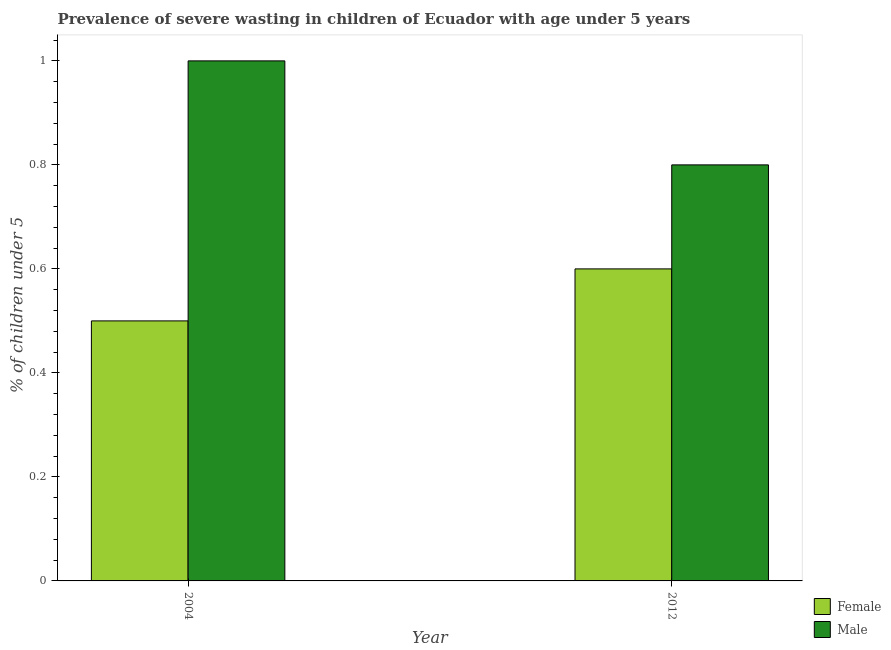How many different coloured bars are there?
Give a very brief answer. 2. Are the number of bars on each tick of the X-axis equal?
Provide a succinct answer. Yes. How many bars are there on the 1st tick from the left?
Keep it short and to the point. 2. What is the label of the 2nd group of bars from the left?
Provide a short and direct response. 2012. In how many cases, is the number of bars for a given year not equal to the number of legend labels?
Offer a terse response. 0. What is the percentage of undernourished female children in 2004?
Provide a short and direct response. 0.5. Across all years, what is the maximum percentage of undernourished female children?
Ensure brevity in your answer.  0.6. Across all years, what is the minimum percentage of undernourished male children?
Offer a very short reply. 0.8. In which year was the percentage of undernourished male children maximum?
Provide a short and direct response. 2004. In which year was the percentage of undernourished female children minimum?
Your answer should be compact. 2004. What is the total percentage of undernourished female children in the graph?
Offer a terse response. 1.1. What is the difference between the percentage of undernourished female children in 2004 and that in 2012?
Your answer should be compact. -0.1. What is the difference between the percentage of undernourished male children in 2012 and the percentage of undernourished female children in 2004?
Ensure brevity in your answer.  -0.2. What is the average percentage of undernourished male children per year?
Offer a terse response. 0.9. In the year 2012, what is the difference between the percentage of undernourished female children and percentage of undernourished male children?
Offer a terse response. 0. What is the ratio of the percentage of undernourished male children in 2004 to that in 2012?
Provide a succinct answer. 1.25. What does the 1st bar from the left in 2004 represents?
Give a very brief answer. Female. How many years are there in the graph?
Provide a short and direct response. 2. How many legend labels are there?
Give a very brief answer. 2. How are the legend labels stacked?
Ensure brevity in your answer.  Vertical. What is the title of the graph?
Keep it short and to the point. Prevalence of severe wasting in children of Ecuador with age under 5 years. What is the label or title of the X-axis?
Your response must be concise. Year. What is the label or title of the Y-axis?
Provide a succinct answer.  % of children under 5. What is the  % of children under 5 of Female in 2004?
Your response must be concise. 0.5. What is the  % of children under 5 of Female in 2012?
Keep it short and to the point. 0.6. What is the  % of children under 5 of Male in 2012?
Give a very brief answer. 0.8. Across all years, what is the maximum  % of children under 5 in Female?
Provide a succinct answer. 0.6. Across all years, what is the minimum  % of children under 5 in Female?
Your answer should be very brief. 0.5. Across all years, what is the minimum  % of children under 5 of Male?
Give a very brief answer. 0.8. What is the total  % of children under 5 of Male in the graph?
Offer a very short reply. 1.8. What is the difference between the  % of children under 5 in Female in 2004 and that in 2012?
Your answer should be compact. -0.1. What is the difference between the  % of children under 5 of Male in 2004 and that in 2012?
Ensure brevity in your answer.  0.2. What is the average  % of children under 5 in Female per year?
Offer a very short reply. 0.55. What is the average  % of children under 5 of Male per year?
Offer a terse response. 0.9. What is the ratio of the  % of children under 5 of Male in 2004 to that in 2012?
Offer a terse response. 1.25. What is the difference between the highest and the second highest  % of children under 5 of Female?
Your response must be concise. 0.1. What is the difference between the highest and the second highest  % of children under 5 in Male?
Give a very brief answer. 0.2. What is the difference between the highest and the lowest  % of children under 5 in Female?
Your response must be concise. 0.1. What is the difference between the highest and the lowest  % of children under 5 of Male?
Your answer should be very brief. 0.2. 